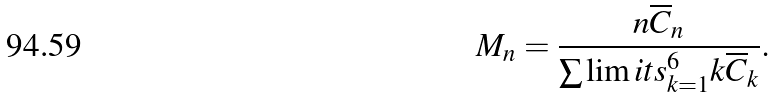<formula> <loc_0><loc_0><loc_500><loc_500>M _ { n } = \frac { n \overline { C } _ { n } } { \sum \lim i t s _ { k = 1 } ^ { 6 } k \overline { C } _ { k } } .</formula> 